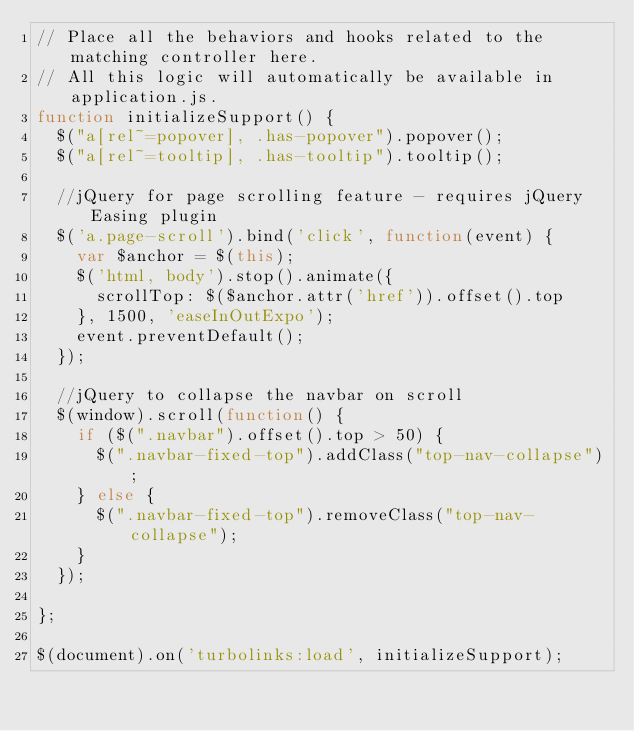Convert code to text. <code><loc_0><loc_0><loc_500><loc_500><_JavaScript_>// Place all the behaviors and hooks related to the matching controller here.
// All this logic will automatically be available in application.js.
function initializeSupport() {
  $("a[rel~=popover], .has-popover").popover();
  $("a[rel~=tooltip], .has-tooltip").tooltip();

  //jQuery for page scrolling feature - requires jQuery Easing plugin
  $('a.page-scroll').bind('click', function(event) {
    var $anchor = $(this);
    $('html, body').stop().animate({
      scrollTop: $($anchor.attr('href')).offset().top
    }, 1500, 'easeInOutExpo');
    event.preventDefault();
  });

  //jQuery to collapse the navbar on scroll
  $(window).scroll(function() {
    if ($(".navbar").offset().top > 50) {
      $(".navbar-fixed-top").addClass("top-nav-collapse");
    } else {
      $(".navbar-fixed-top").removeClass("top-nav-collapse");
    }
  });

};

$(document).on('turbolinks:load', initializeSupport);

</code> 